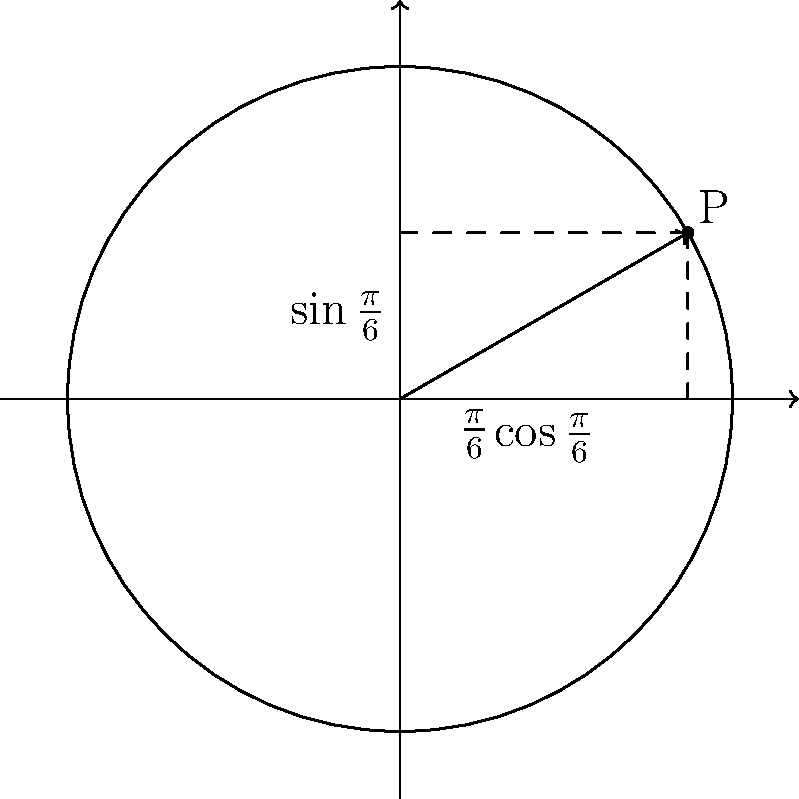In the unit circle shown above, point P represents an angle of $\frac{\pi}{6}$ radians. Using this information, determine the exact value of $\tan \frac{\pi}{6}$. To find $\tan \frac{\pi}{6}$, we can follow these steps:

1) Recall that $\tan \theta = \frac{\sin \theta}{\cos \theta}$

2) From the unit circle, we can see that:
   $\cos \frac{\pi}{6} = \frac{\sqrt{3}}{2}$ (x-coordinate)
   $\sin \frac{\pi}{6} = \frac{1}{2}$ (y-coordinate)

3) Substituting these values into the tangent formula:

   $\tan \frac{\pi}{6} = \frac{\sin \frac{\pi}{6}}{\cos \frac{\pi}{6}} = \frac{\frac{1}{2}}{\frac{\sqrt{3}}{2}}$

4) Simplify by multiplying both numerator and denominator by 2:

   $\tan \frac{\pi}{6} = \frac{1}{\sqrt{3}}$

5) To rationalize the denominator, multiply both numerator and denominator by $\sqrt{3}$:

   $\tan \frac{\pi}{6} = \frac{1}{\sqrt{3}} \cdot \frac{\sqrt{3}}{\sqrt{3}} = \frac{\sqrt{3}}{3}$

Therefore, the exact value of $\tan \frac{\pi}{6}$ is $\frac{\sqrt{3}}{3}$.
Answer: $\frac{\sqrt{3}}{3}$ 